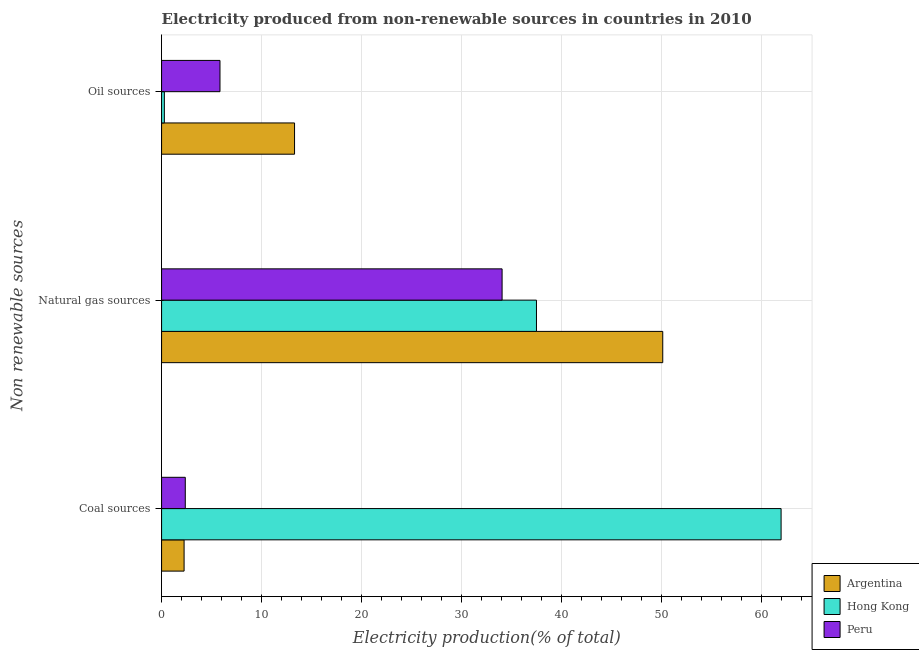How many groups of bars are there?
Your answer should be compact. 3. Are the number of bars per tick equal to the number of legend labels?
Your response must be concise. Yes. Are the number of bars on each tick of the Y-axis equal?
Make the answer very short. Yes. How many bars are there on the 1st tick from the top?
Give a very brief answer. 3. What is the label of the 2nd group of bars from the top?
Provide a succinct answer. Natural gas sources. What is the percentage of electricity produced by oil sources in Peru?
Ensure brevity in your answer.  5.84. Across all countries, what is the maximum percentage of electricity produced by oil sources?
Your answer should be very brief. 13.3. Across all countries, what is the minimum percentage of electricity produced by coal?
Offer a terse response. 2.25. In which country was the percentage of electricity produced by coal maximum?
Your answer should be compact. Hong Kong. What is the total percentage of electricity produced by natural gas in the graph?
Offer a very short reply. 121.71. What is the difference between the percentage of electricity produced by oil sources in Hong Kong and that in Peru?
Your answer should be compact. -5.56. What is the difference between the percentage of electricity produced by natural gas in Argentina and the percentage of electricity produced by coal in Hong Kong?
Provide a short and direct response. -11.84. What is the average percentage of electricity produced by oil sources per country?
Your answer should be compact. 6.47. What is the difference between the percentage of electricity produced by natural gas and percentage of electricity produced by oil sources in Peru?
Your response must be concise. 28.22. What is the ratio of the percentage of electricity produced by coal in Peru to that in Hong Kong?
Give a very brief answer. 0.04. Is the percentage of electricity produced by oil sources in Peru less than that in Argentina?
Your answer should be compact. Yes. Is the difference between the percentage of electricity produced by oil sources in Peru and Hong Kong greater than the difference between the percentage of electricity produced by coal in Peru and Hong Kong?
Provide a short and direct response. Yes. What is the difference between the highest and the second highest percentage of electricity produced by oil sources?
Provide a succinct answer. 7.46. What is the difference between the highest and the lowest percentage of electricity produced by oil sources?
Make the answer very short. 13.02. In how many countries, is the percentage of electricity produced by oil sources greater than the average percentage of electricity produced by oil sources taken over all countries?
Offer a terse response. 1. What does the 2nd bar from the top in Natural gas sources represents?
Your response must be concise. Hong Kong. Are all the bars in the graph horizontal?
Offer a very short reply. Yes. How many countries are there in the graph?
Keep it short and to the point. 3. What is the difference between two consecutive major ticks on the X-axis?
Your answer should be very brief. 10. Are the values on the major ticks of X-axis written in scientific E-notation?
Give a very brief answer. No. Does the graph contain any zero values?
Offer a very short reply. No. What is the title of the graph?
Your response must be concise. Electricity produced from non-renewable sources in countries in 2010. Does "Isle of Man" appear as one of the legend labels in the graph?
Provide a short and direct response. No. What is the label or title of the Y-axis?
Offer a very short reply. Non renewable sources. What is the Electricity production(% of total) in Argentina in Coal sources?
Ensure brevity in your answer.  2.25. What is the Electricity production(% of total) of Hong Kong in Coal sources?
Provide a succinct answer. 61.98. What is the Electricity production(% of total) of Peru in Coal sources?
Provide a succinct answer. 2.37. What is the Electricity production(% of total) of Argentina in Natural gas sources?
Offer a terse response. 50.14. What is the Electricity production(% of total) of Hong Kong in Natural gas sources?
Offer a very short reply. 37.5. What is the Electricity production(% of total) in Peru in Natural gas sources?
Offer a very short reply. 34.07. What is the Electricity production(% of total) in Argentina in Oil sources?
Give a very brief answer. 13.3. What is the Electricity production(% of total) of Hong Kong in Oil sources?
Offer a very short reply. 0.28. What is the Electricity production(% of total) of Peru in Oil sources?
Offer a terse response. 5.84. Across all Non renewable sources, what is the maximum Electricity production(% of total) of Argentina?
Offer a terse response. 50.14. Across all Non renewable sources, what is the maximum Electricity production(% of total) of Hong Kong?
Give a very brief answer. 61.98. Across all Non renewable sources, what is the maximum Electricity production(% of total) of Peru?
Make the answer very short. 34.07. Across all Non renewable sources, what is the minimum Electricity production(% of total) in Argentina?
Provide a succinct answer. 2.25. Across all Non renewable sources, what is the minimum Electricity production(% of total) in Hong Kong?
Provide a succinct answer. 0.28. Across all Non renewable sources, what is the minimum Electricity production(% of total) in Peru?
Your response must be concise. 2.37. What is the total Electricity production(% of total) in Argentina in the graph?
Your answer should be compact. 65.69. What is the total Electricity production(% of total) in Hong Kong in the graph?
Keep it short and to the point. 99.76. What is the total Electricity production(% of total) of Peru in the graph?
Offer a terse response. 42.28. What is the difference between the Electricity production(% of total) in Argentina in Coal sources and that in Natural gas sources?
Your response must be concise. -47.88. What is the difference between the Electricity production(% of total) in Hong Kong in Coal sources and that in Natural gas sources?
Ensure brevity in your answer.  24.47. What is the difference between the Electricity production(% of total) of Peru in Coal sources and that in Natural gas sources?
Give a very brief answer. -31.69. What is the difference between the Electricity production(% of total) of Argentina in Coal sources and that in Oil sources?
Your answer should be very brief. -11.05. What is the difference between the Electricity production(% of total) in Hong Kong in Coal sources and that in Oil sources?
Provide a succinct answer. 61.7. What is the difference between the Electricity production(% of total) in Peru in Coal sources and that in Oil sources?
Offer a terse response. -3.47. What is the difference between the Electricity production(% of total) in Argentina in Natural gas sources and that in Oil sources?
Your answer should be very brief. 36.83. What is the difference between the Electricity production(% of total) in Hong Kong in Natural gas sources and that in Oil sources?
Offer a terse response. 37.23. What is the difference between the Electricity production(% of total) in Peru in Natural gas sources and that in Oil sources?
Your answer should be compact. 28.22. What is the difference between the Electricity production(% of total) in Argentina in Coal sources and the Electricity production(% of total) in Hong Kong in Natural gas sources?
Give a very brief answer. -35.25. What is the difference between the Electricity production(% of total) in Argentina in Coal sources and the Electricity production(% of total) in Peru in Natural gas sources?
Your answer should be very brief. -31.81. What is the difference between the Electricity production(% of total) in Hong Kong in Coal sources and the Electricity production(% of total) in Peru in Natural gas sources?
Make the answer very short. 27.91. What is the difference between the Electricity production(% of total) of Argentina in Coal sources and the Electricity production(% of total) of Hong Kong in Oil sources?
Offer a very short reply. 1.97. What is the difference between the Electricity production(% of total) in Argentina in Coal sources and the Electricity production(% of total) in Peru in Oil sources?
Keep it short and to the point. -3.59. What is the difference between the Electricity production(% of total) of Hong Kong in Coal sources and the Electricity production(% of total) of Peru in Oil sources?
Offer a very short reply. 56.13. What is the difference between the Electricity production(% of total) in Argentina in Natural gas sources and the Electricity production(% of total) in Hong Kong in Oil sources?
Your response must be concise. 49.86. What is the difference between the Electricity production(% of total) of Argentina in Natural gas sources and the Electricity production(% of total) of Peru in Oil sources?
Offer a very short reply. 44.29. What is the difference between the Electricity production(% of total) of Hong Kong in Natural gas sources and the Electricity production(% of total) of Peru in Oil sources?
Give a very brief answer. 31.66. What is the average Electricity production(% of total) of Argentina per Non renewable sources?
Your answer should be very brief. 21.9. What is the average Electricity production(% of total) in Hong Kong per Non renewable sources?
Offer a terse response. 33.25. What is the average Electricity production(% of total) of Peru per Non renewable sources?
Your answer should be compact. 14.09. What is the difference between the Electricity production(% of total) of Argentina and Electricity production(% of total) of Hong Kong in Coal sources?
Your answer should be very brief. -59.72. What is the difference between the Electricity production(% of total) of Argentina and Electricity production(% of total) of Peru in Coal sources?
Keep it short and to the point. -0.12. What is the difference between the Electricity production(% of total) in Hong Kong and Electricity production(% of total) in Peru in Coal sources?
Your response must be concise. 59.6. What is the difference between the Electricity production(% of total) in Argentina and Electricity production(% of total) in Hong Kong in Natural gas sources?
Offer a very short reply. 12.63. What is the difference between the Electricity production(% of total) of Argentina and Electricity production(% of total) of Peru in Natural gas sources?
Offer a very short reply. 16.07. What is the difference between the Electricity production(% of total) of Hong Kong and Electricity production(% of total) of Peru in Natural gas sources?
Give a very brief answer. 3.44. What is the difference between the Electricity production(% of total) in Argentina and Electricity production(% of total) in Hong Kong in Oil sources?
Your answer should be very brief. 13.02. What is the difference between the Electricity production(% of total) in Argentina and Electricity production(% of total) in Peru in Oil sources?
Your answer should be very brief. 7.46. What is the difference between the Electricity production(% of total) of Hong Kong and Electricity production(% of total) of Peru in Oil sources?
Your answer should be compact. -5.56. What is the ratio of the Electricity production(% of total) of Argentina in Coal sources to that in Natural gas sources?
Offer a very short reply. 0.04. What is the ratio of the Electricity production(% of total) in Hong Kong in Coal sources to that in Natural gas sources?
Your answer should be compact. 1.65. What is the ratio of the Electricity production(% of total) in Peru in Coal sources to that in Natural gas sources?
Offer a very short reply. 0.07. What is the ratio of the Electricity production(% of total) in Argentina in Coal sources to that in Oil sources?
Provide a succinct answer. 0.17. What is the ratio of the Electricity production(% of total) in Hong Kong in Coal sources to that in Oil sources?
Your answer should be very brief. 222.35. What is the ratio of the Electricity production(% of total) in Peru in Coal sources to that in Oil sources?
Provide a succinct answer. 0.41. What is the ratio of the Electricity production(% of total) of Argentina in Natural gas sources to that in Oil sources?
Offer a very short reply. 3.77. What is the ratio of the Electricity production(% of total) in Hong Kong in Natural gas sources to that in Oil sources?
Your answer should be very brief. 134.55. What is the ratio of the Electricity production(% of total) in Peru in Natural gas sources to that in Oil sources?
Your answer should be very brief. 5.83. What is the difference between the highest and the second highest Electricity production(% of total) of Argentina?
Your answer should be compact. 36.83. What is the difference between the highest and the second highest Electricity production(% of total) in Hong Kong?
Keep it short and to the point. 24.47. What is the difference between the highest and the second highest Electricity production(% of total) in Peru?
Make the answer very short. 28.22. What is the difference between the highest and the lowest Electricity production(% of total) in Argentina?
Provide a succinct answer. 47.88. What is the difference between the highest and the lowest Electricity production(% of total) of Hong Kong?
Provide a succinct answer. 61.7. What is the difference between the highest and the lowest Electricity production(% of total) in Peru?
Offer a terse response. 31.69. 